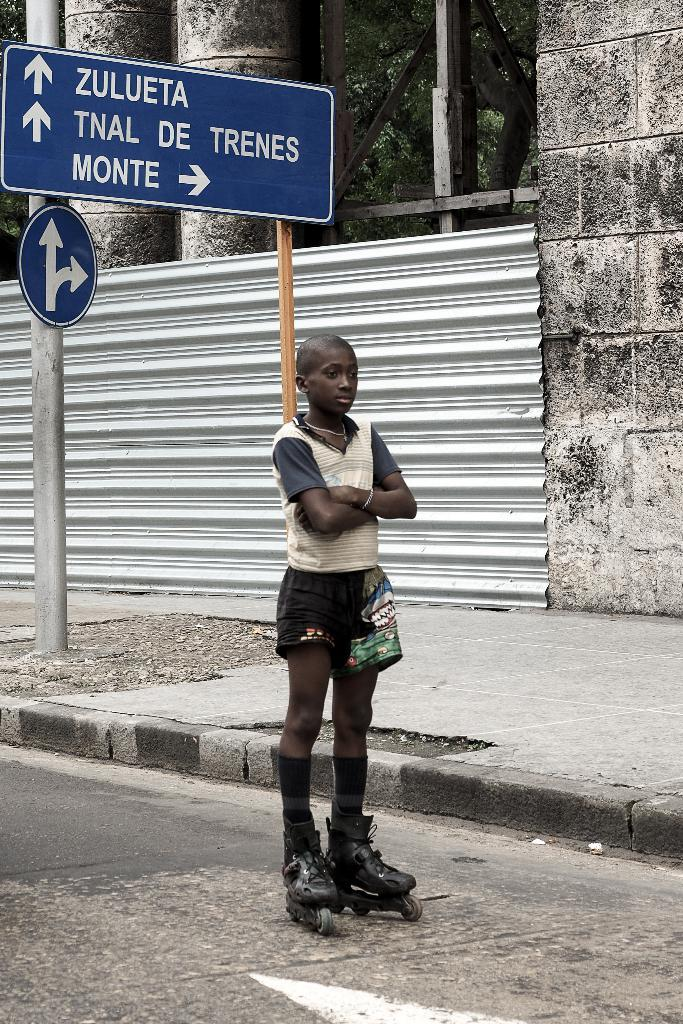What is the main subject of the image? There is a person in the image. What type of footwear is the person wearing? The person is wearing skating shoes. Where is the person standing in the image? The person is standing on the road. What is the surface next to the road in the image? There is a sidewalk in the image. Can you describe the structure with two boards in the image? There is a pole with two boards in the image. What can be seen in the background of the image? There is a wall and trees in the background of the image. What is the purpose of the landfill in the image? There is no landfill present in the image. What type of waste is being disposed of in the image? There is no waste disposal activity depicted in the image. 